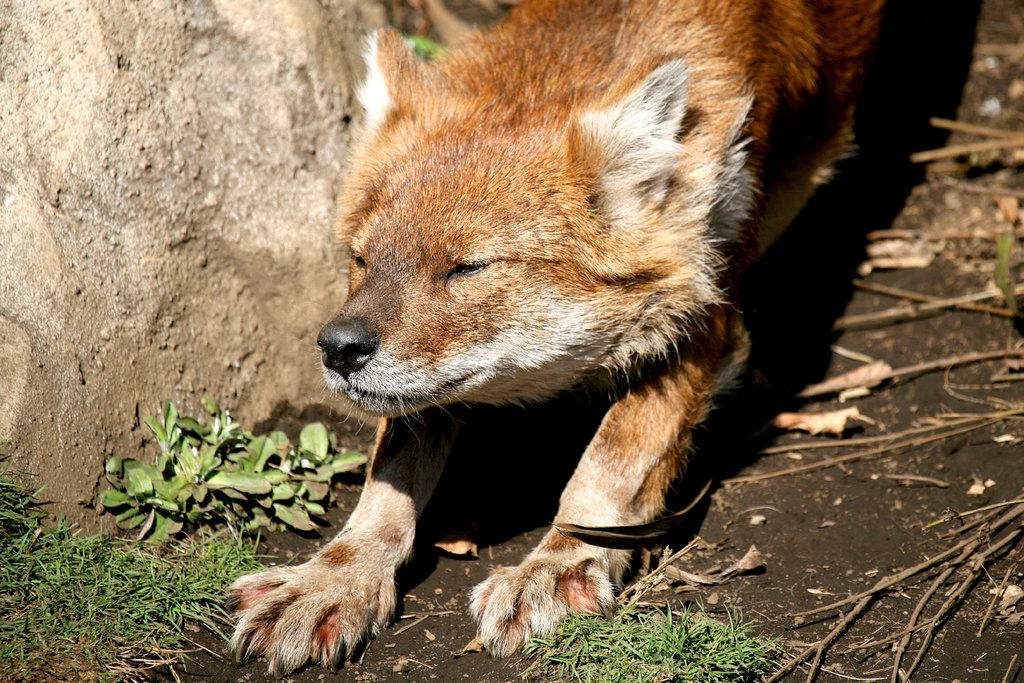What animal can be seen in the image? There is a fox in the image. What object is located beside the fox? There is a rock beside the fox. What type of vegetation is present in front of the fox? There is grass on the surface in front of the fox. What type of argument is the fox having with the owl in the image? There is no owl present in the image, so there cannot be an argument between the fox and an owl. 